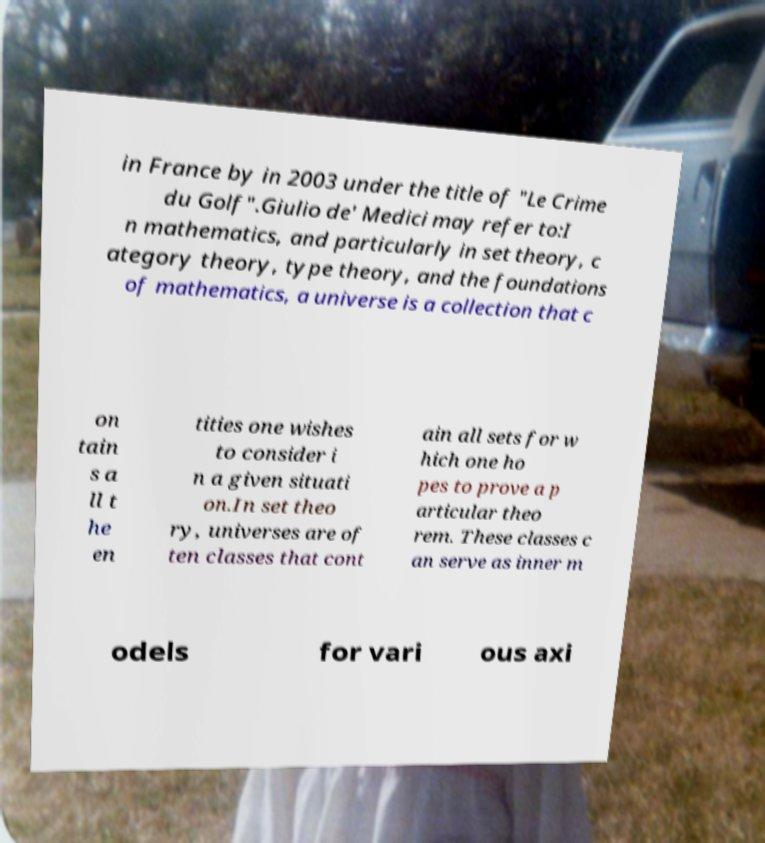Can you accurately transcribe the text from the provided image for me? in France by in 2003 under the title of "Le Crime du Golf".Giulio de' Medici may refer to:I n mathematics, and particularly in set theory, c ategory theory, type theory, and the foundations of mathematics, a universe is a collection that c on tain s a ll t he en tities one wishes to consider i n a given situati on.In set theo ry, universes are of ten classes that cont ain all sets for w hich one ho pes to prove a p articular theo rem. These classes c an serve as inner m odels for vari ous axi 